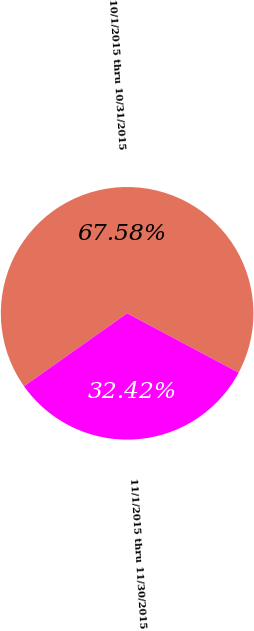Convert chart to OTSL. <chart><loc_0><loc_0><loc_500><loc_500><pie_chart><fcel>10/1/2015 thru 10/31/2015<fcel>11/1/2015 thru 11/30/2015<nl><fcel>67.58%<fcel>32.42%<nl></chart> 